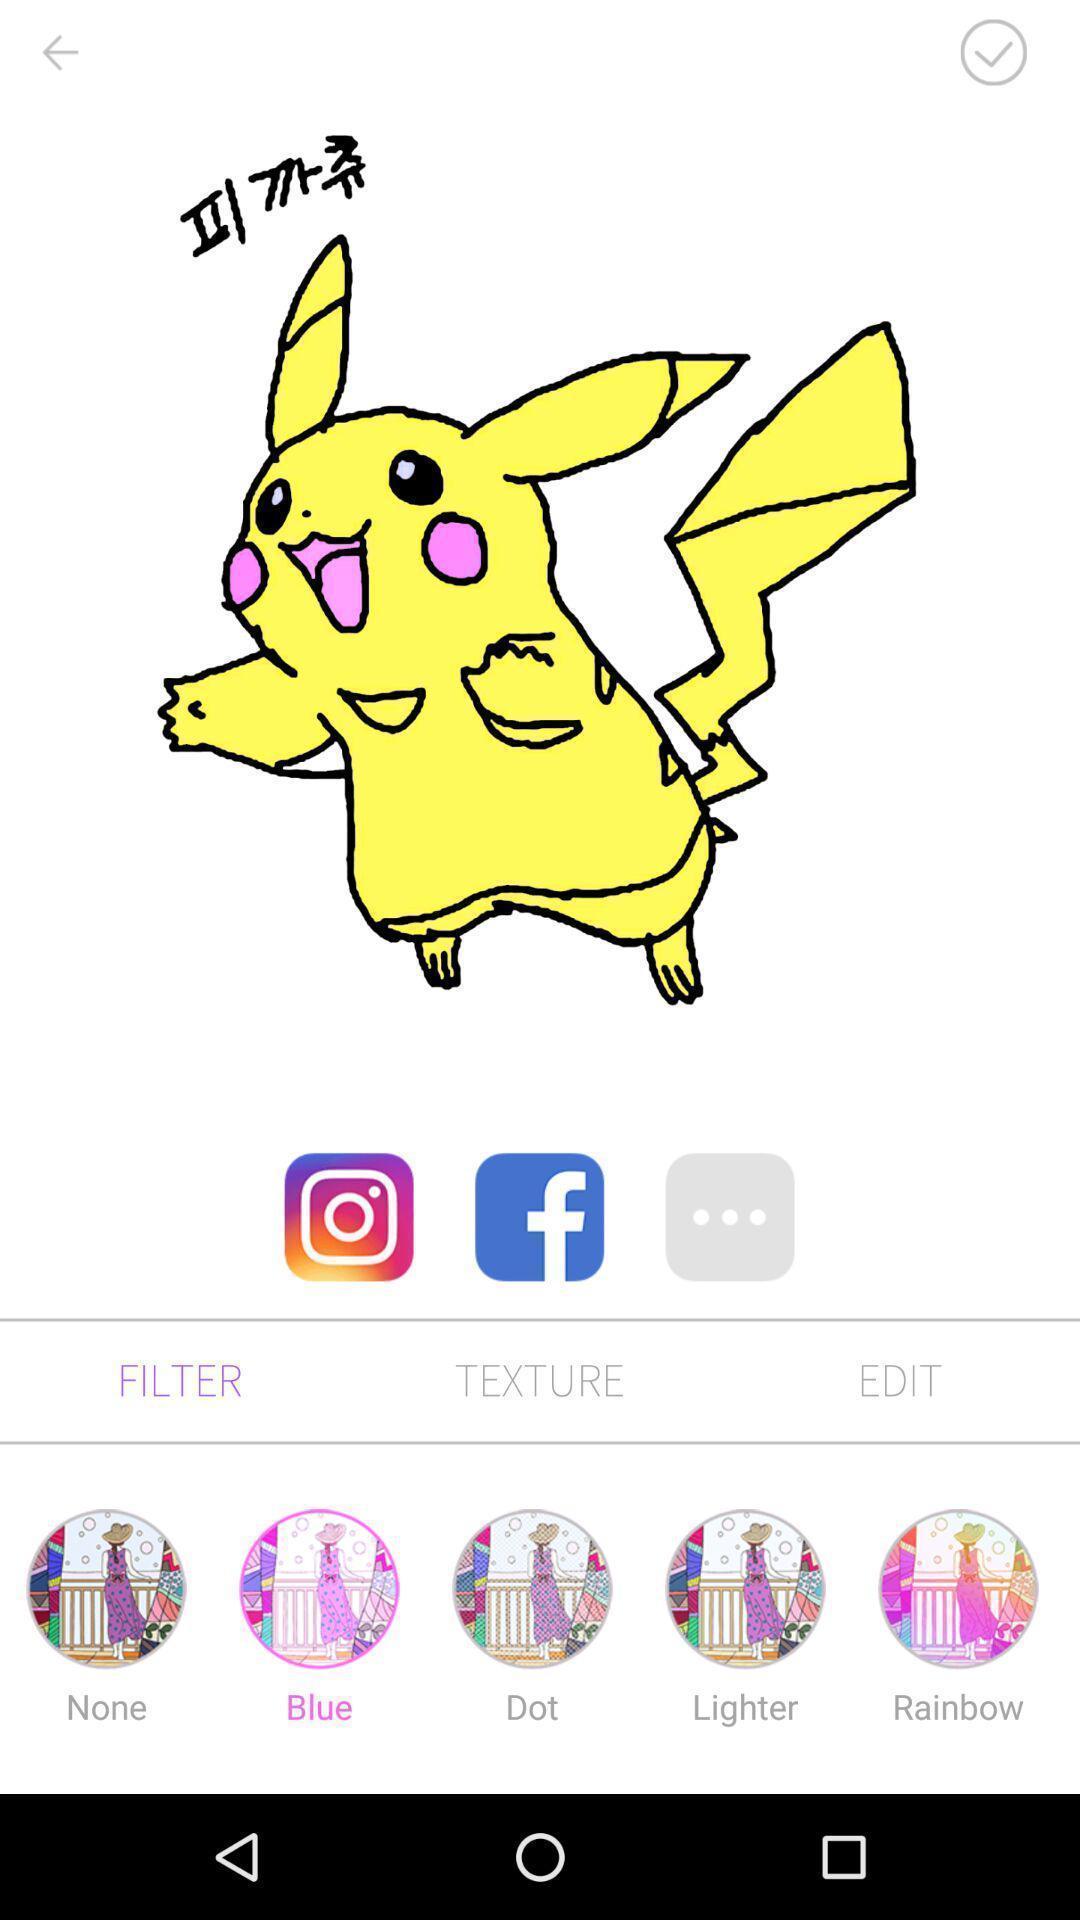Tell me what you see in this picture. Page displays a cartoon picture in editing app. 